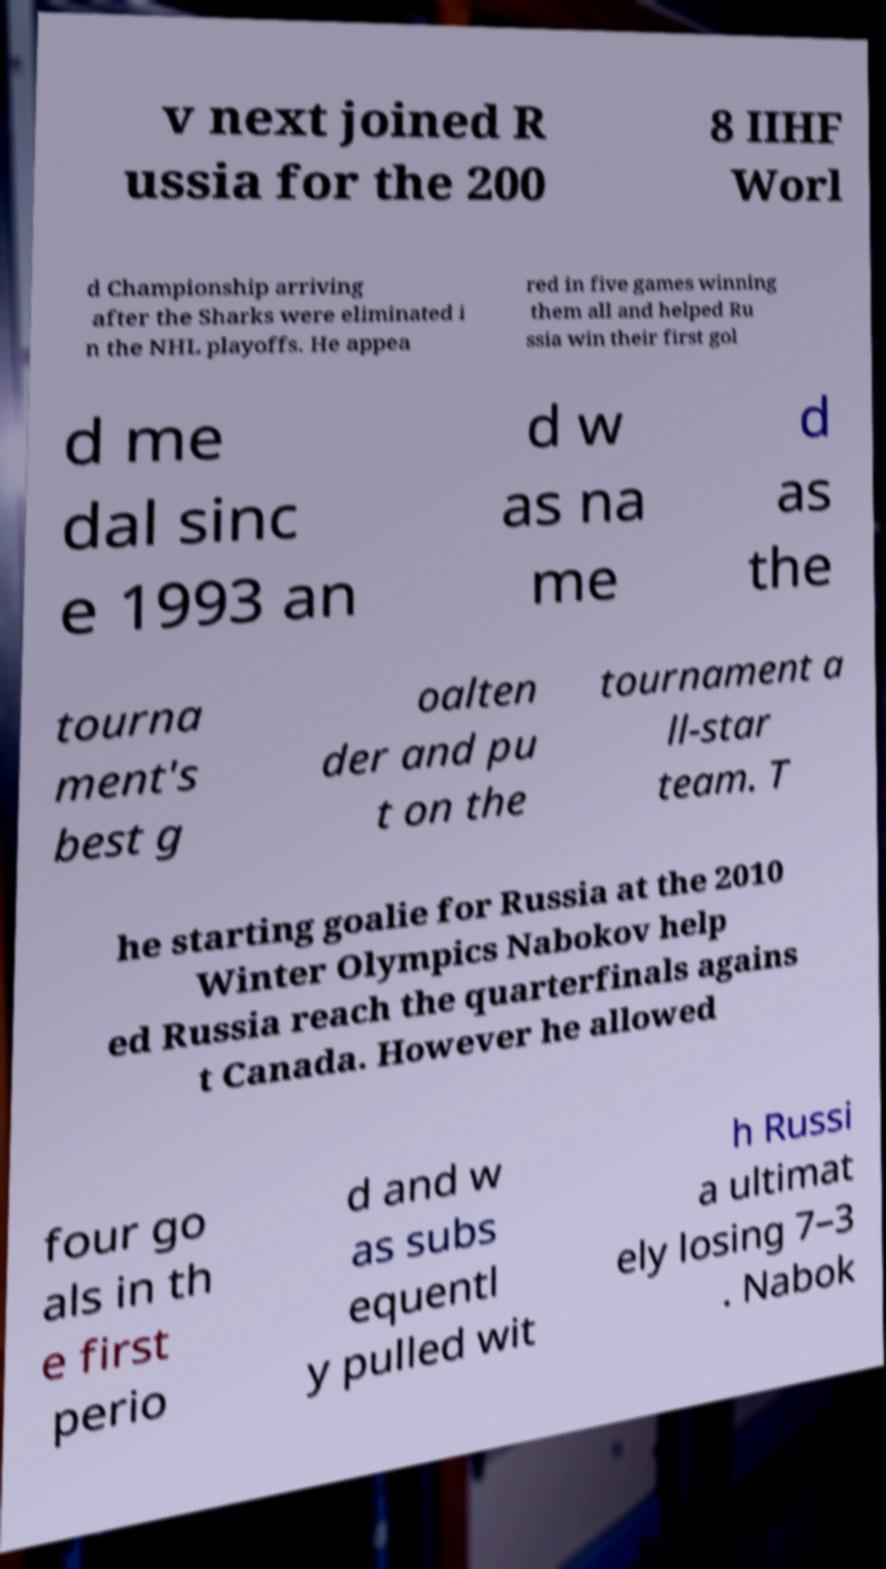For documentation purposes, I need the text within this image transcribed. Could you provide that? v next joined R ussia for the 200 8 IIHF Worl d Championship arriving after the Sharks were eliminated i n the NHL playoffs. He appea red in five games winning them all and helped Ru ssia win their first gol d me dal sinc e 1993 an d w as na me d as the tourna ment's best g oalten der and pu t on the tournament a ll-star team. T he starting goalie for Russia at the 2010 Winter Olympics Nabokov help ed Russia reach the quarterfinals agains t Canada. However he allowed four go als in th e first perio d and w as subs equentl y pulled wit h Russi a ultimat ely losing 7–3 . Nabok 